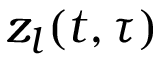<formula> <loc_0><loc_0><loc_500><loc_500>z _ { l } ( t , \tau )</formula> 